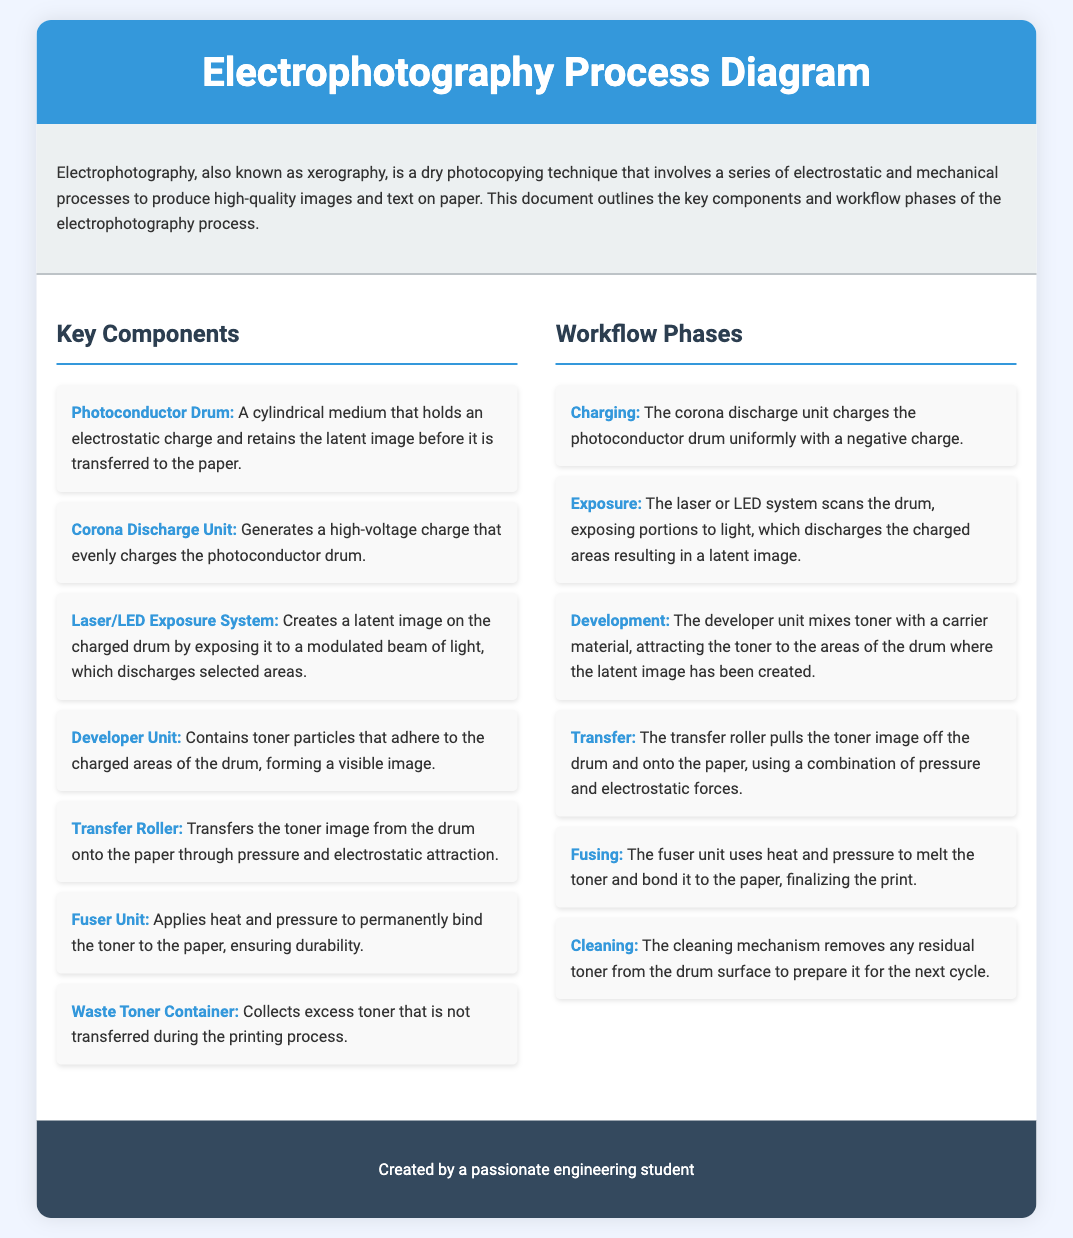What is another name for electrophotography? The document states that electrophotography is also known as xerography.
Answer: xerography How many key components are listed in the document? The document provides a list of seven key components under "Key Components."
Answer: 7 What does the corona discharge unit do? According to the document, the corona discharge unit generates a high-voltage charge that evenly charges the photoconductor drum.
Answer: generates a high-voltage charge What is the first phase of the electrophotography workflow? The document outlines the first phase as "Charging."
Answer: Charging Which component permanently binds toner to the paper? The document specifies that the fuser unit applies heat and pressure to permanently bind the toner to the paper.
Answer: fuser unit What is the purpose of the waste toner container? The document states that the waste toner container collects excess toner that is not transferred during the printing process.
Answer: collects excess toner What are the two forces used in the transfer phase? The document indicates that the transfer roller uses pressure and electrostatic forces to pull the toner image off the drum.
Answer: pressure and electrostatic forces What mechanism is used in the cleaning phase? The cleaning mechanism removes any residual toner from the drum surface.
Answer: cleaning mechanism 